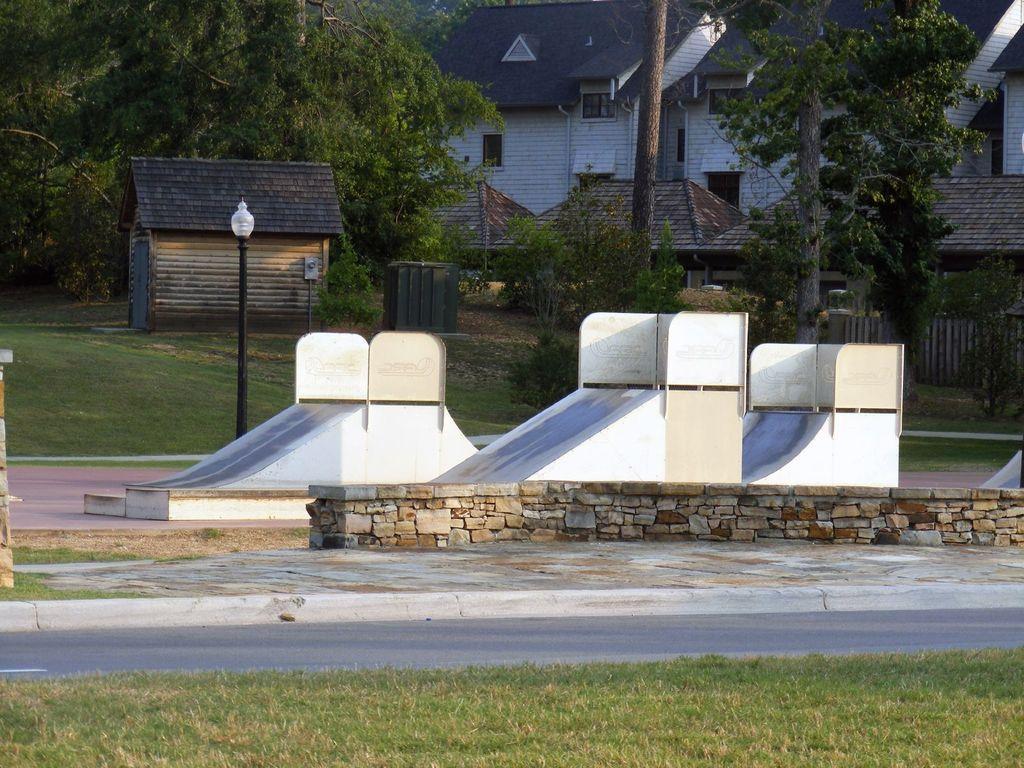Could you give a brief overview of what you see in this image? This picture is clicked outside. In the foreground we can see the grass. In the center there are some white color objects and a lamp attached to the pole and we can see the plants, trees, huts and some houses. 